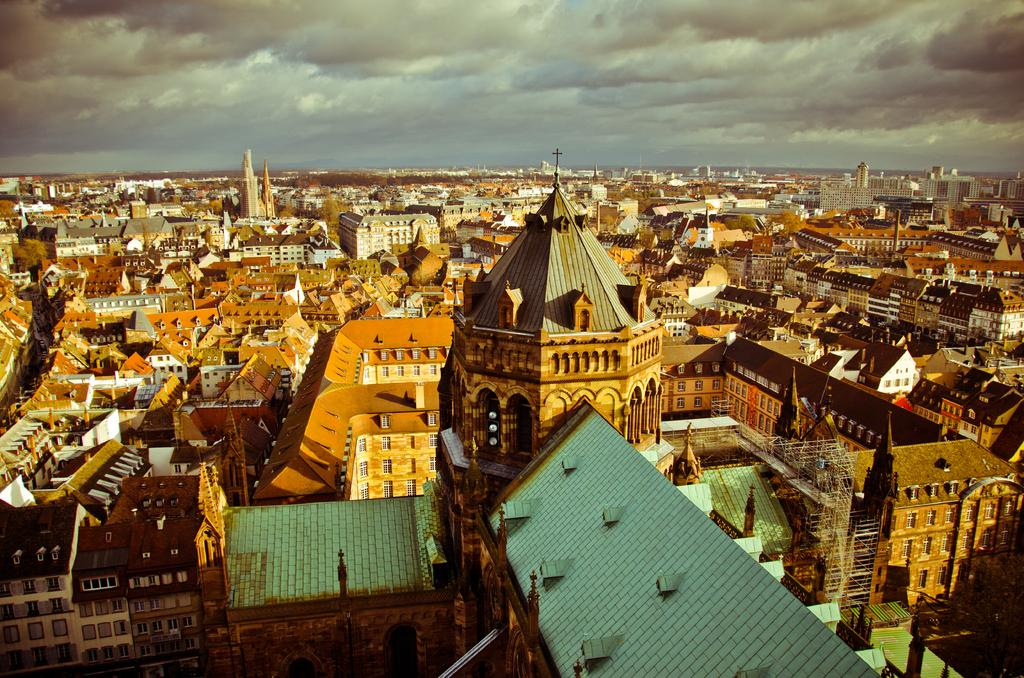What type of structures can be seen in the image? There are houses in the image. What part of the natural environment is visible in the image? The sky is visible in the background of the image. What type of gate can be seen in the image? There is no gate present in the image; only houses and the sky are visible. What mountain range can be seen in the background of the image? There is no mountain range present in the image; only houses and the sky are visible. 